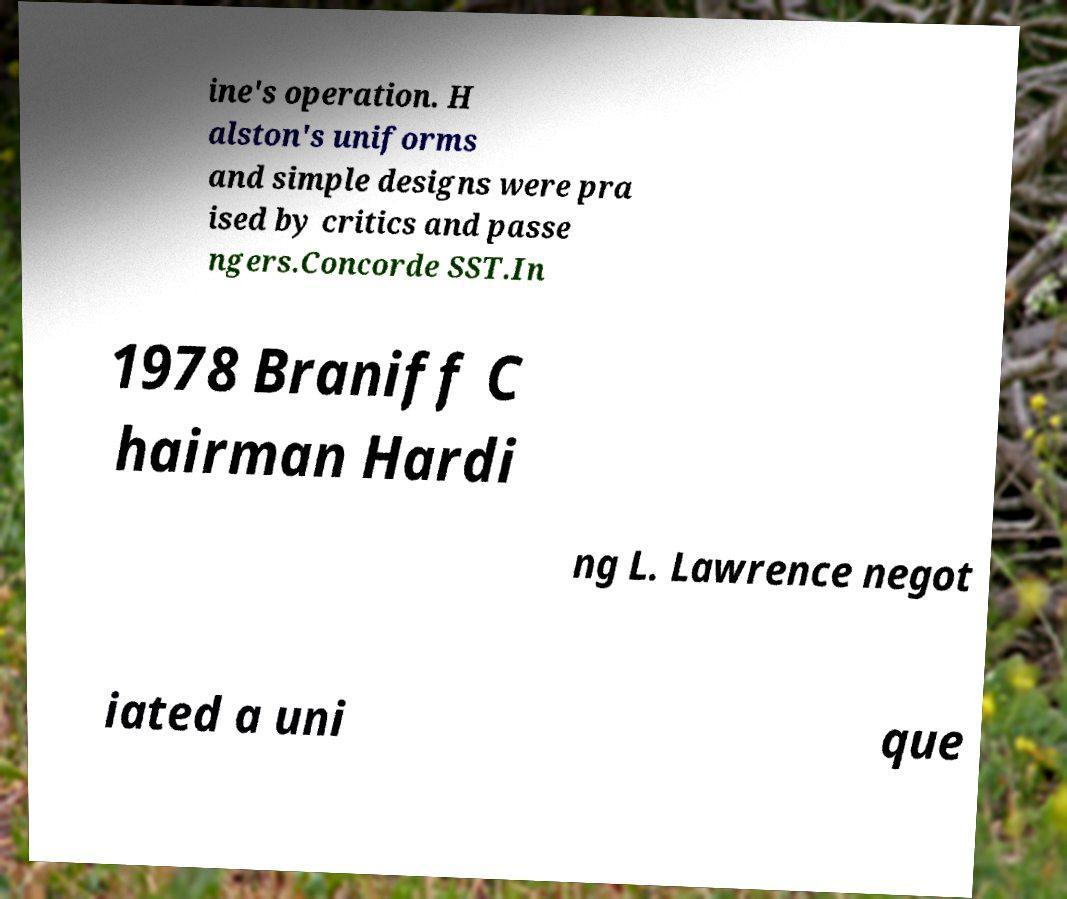I need the written content from this picture converted into text. Can you do that? ine's operation. H alston's uniforms and simple designs were pra ised by critics and passe ngers.Concorde SST.In 1978 Braniff C hairman Hardi ng L. Lawrence negot iated a uni que 